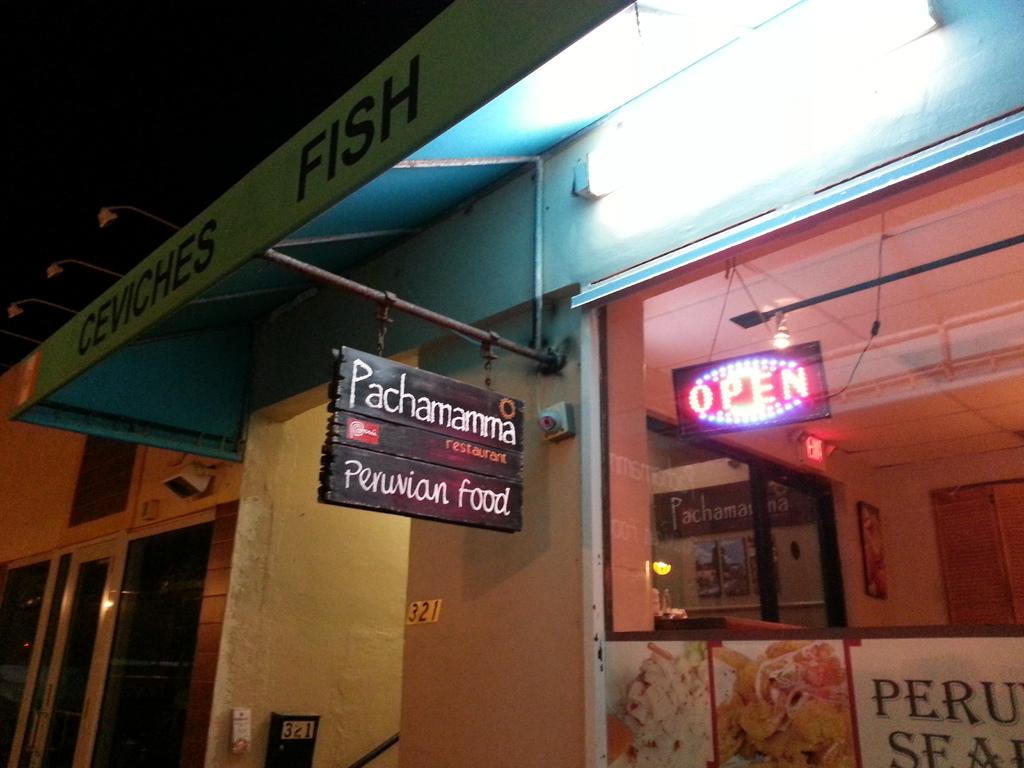What the hell is pachamamma?
Provide a succinct answer. Peruvian food. What kind of meat does this restaurant make?
Provide a short and direct response. Fish. 